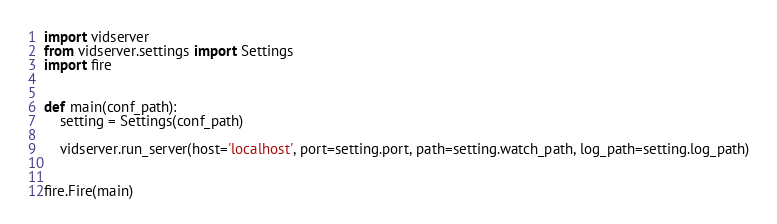Convert code to text. <code><loc_0><loc_0><loc_500><loc_500><_Python_>
import vidserver
from vidserver.settings import Settings
import fire


def main(conf_path):
    setting = Settings(conf_path)

    vidserver.run_server(host='localhost', port=setting.port, path=setting.watch_path, log_path=setting.log_path)


fire.Fire(main)
</code> 